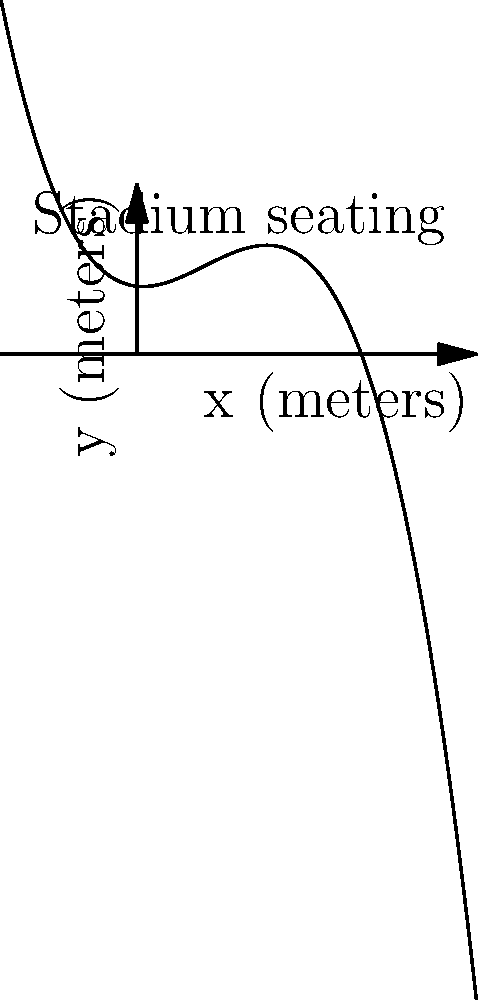The seating arrangement of a football stadium can be modeled by the polynomial function $f(x) = -0.0005x^3 + 0.03x^2 - 0.1x + 20$, where $x$ represents the horizontal distance from the center of the field (in meters) and $f(x)$ represents the height of the seating (in meters). At what horizontal distance from the center of the field is the seating arrangement at its maximum height? To find the maximum height of the seating arrangement, we need to follow these steps:

1) First, we need to find the derivative of the function:
   $f'(x) = -0.0015x^2 + 0.06x - 0.1$

2) The maximum point occurs where the derivative equals zero. So, let's set $f'(x) = 0$:
   $-0.0015x^2 + 0.06x - 0.1 = 0$

3) This is a quadratic equation. We can solve it using the quadratic formula:
   $x = \frac{-b \pm \sqrt{b^2 - 4ac}}{2a}$

   Where $a = -0.0015$, $b = 0.06$, and $c = -0.1$

4) Plugging these values into the quadratic formula:
   $x = \frac{-0.06 \pm \sqrt{0.06^2 - 4(-0.0015)(-0.1)}}{2(-0.0015)}$

5) Simplifying:
   $x = \frac{-0.06 \pm \sqrt{0.0036 - 0.0006}}{-0.003}$
   $x = \frac{-0.06 \pm \sqrt{0.003}}{-0.003}$
   $x = \frac{-0.06 \pm 0.0548}{-0.003}$

6) This gives us two solutions:
   $x_1 = \frac{-0.06 + 0.0548}{-0.003} \approx 1.73$
   $x_2 = \frac{-0.06 - 0.0548}{-0.003} \approx 38.27$

7) Since we're looking for the maximum height, we choose the larger value, 38.27 meters.

Therefore, the seating arrangement reaches its maximum height at approximately 38.27 meters from the center of the field.
Answer: 38.27 meters 